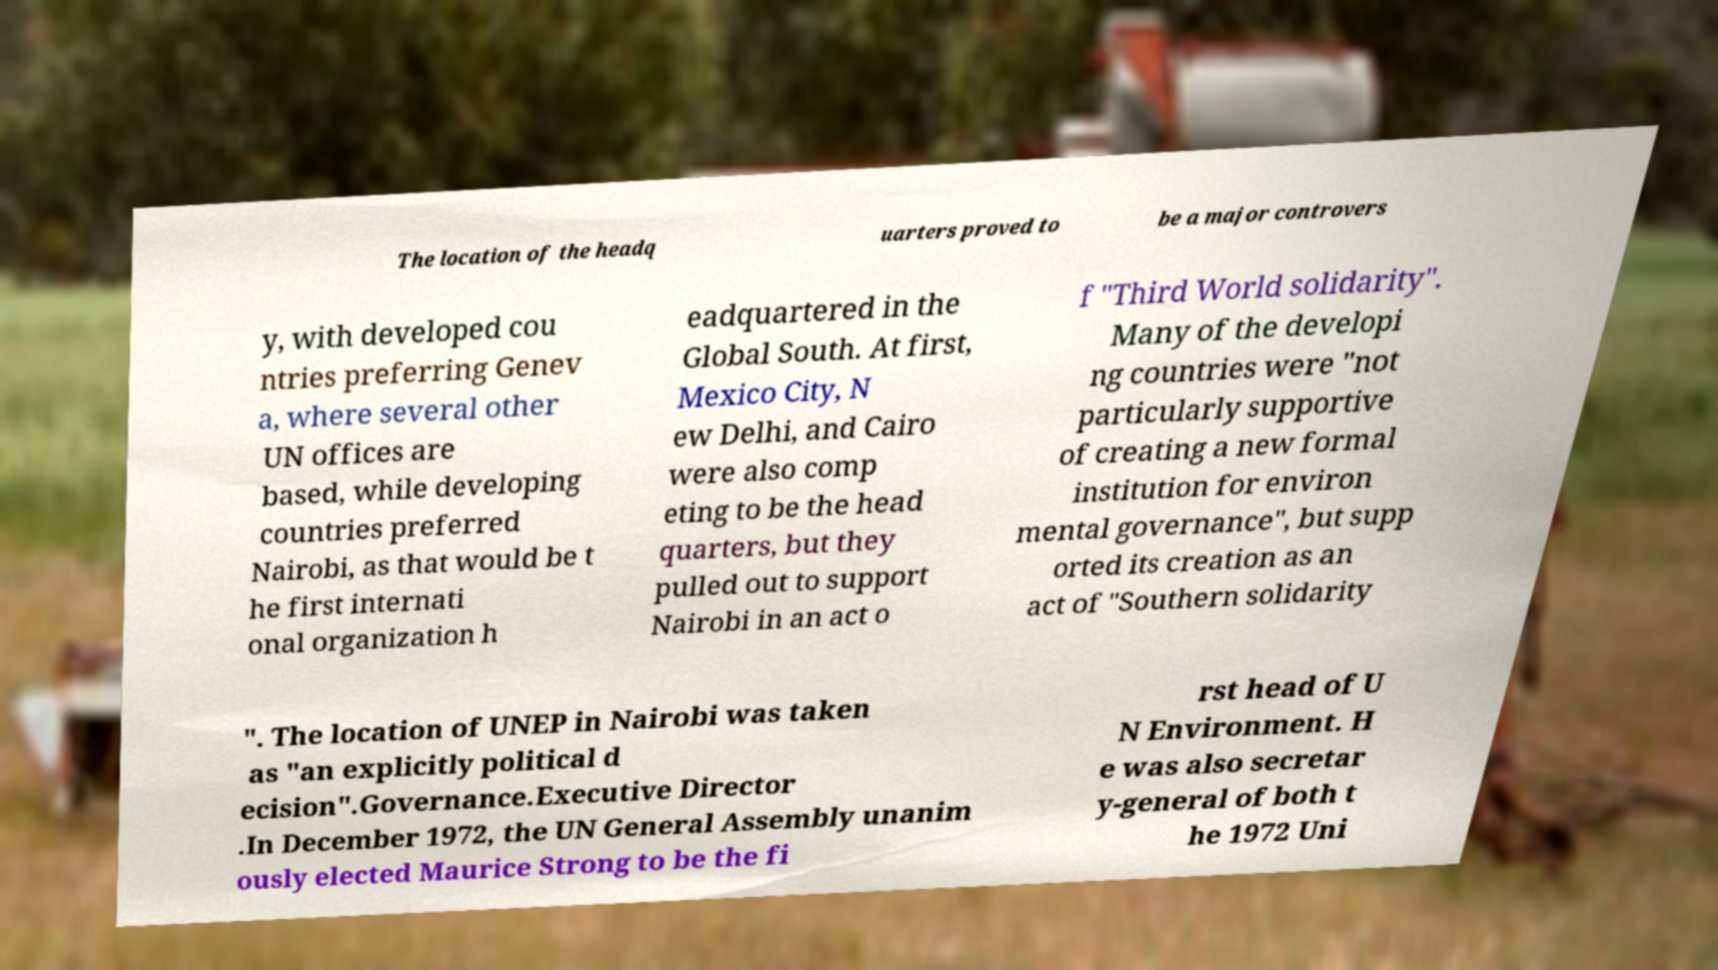Could you extract and type out the text from this image? The location of the headq uarters proved to be a major controvers y, with developed cou ntries preferring Genev a, where several other UN offices are based, while developing countries preferred Nairobi, as that would be t he first internati onal organization h eadquartered in the Global South. At first, Mexico City, N ew Delhi, and Cairo were also comp eting to be the head quarters, but they pulled out to support Nairobi in an act o f "Third World solidarity". Many of the developi ng countries were "not particularly supportive of creating a new formal institution for environ mental governance", but supp orted its creation as an act of "Southern solidarity ". The location of UNEP in Nairobi was taken as "an explicitly political d ecision".Governance.Executive Director .In December 1972, the UN General Assembly unanim ously elected Maurice Strong to be the fi rst head of U N Environment. H e was also secretar y-general of both t he 1972 Uni 